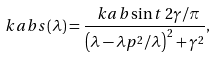Convert formula to latex. <formula><loc_0><loc_0><loc_500><loc_500>\ k a b s ( \lambda ) = \frac { \ k a b \sin t \, 2 \gamma / \pi } { \left ( \lambda - \lambda p ^ { 2 } / \lambda \right ) ^ { 2 } + \gamma ^ { 2 } } ,</formula> 